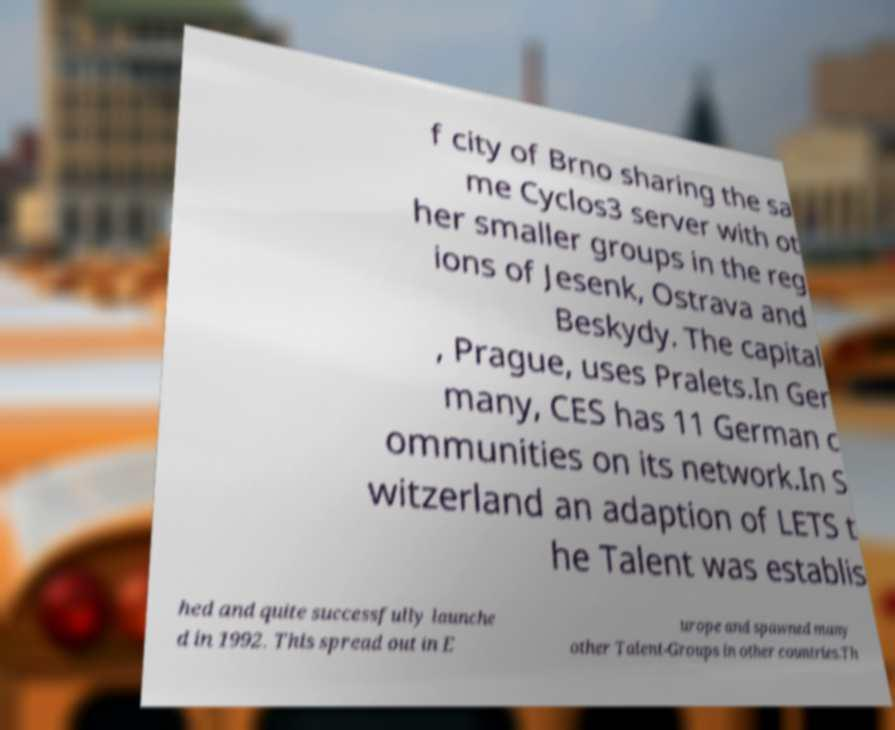For documentation purposes, I need the text within this image transcribed. Could you provide that? f city of Brno sharing the sa me Cyclos3 server with ot her smaller groups in the reg ions of Jesenk, Ostrava and Beskydy. The capital , Prague, uses Pralets.In Ger many, CES has 11 German c ommunities on its network.In S witzerland an adaption of LETS t he Talent was establis hed and quite successfully launche d in 1992. This spread out in E urope and spawned many other Talent-Groups in other countries.Th 